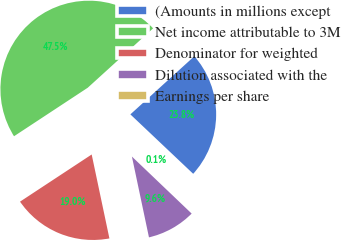<chart> <loc_0><loc_0><loc_500><loc_500><pie_chart><fcel>(Amounts in millions except<fcel>Net income attributable to 3M<fcel>Denominator for weighted<fcel>Dilution associated with the<fcel>Earnings per share<nl><fcel>23.8%<fcel>47.53%<fcel>19.05%<fcel>9.56%<fcel>0.07%<nl></chart> 